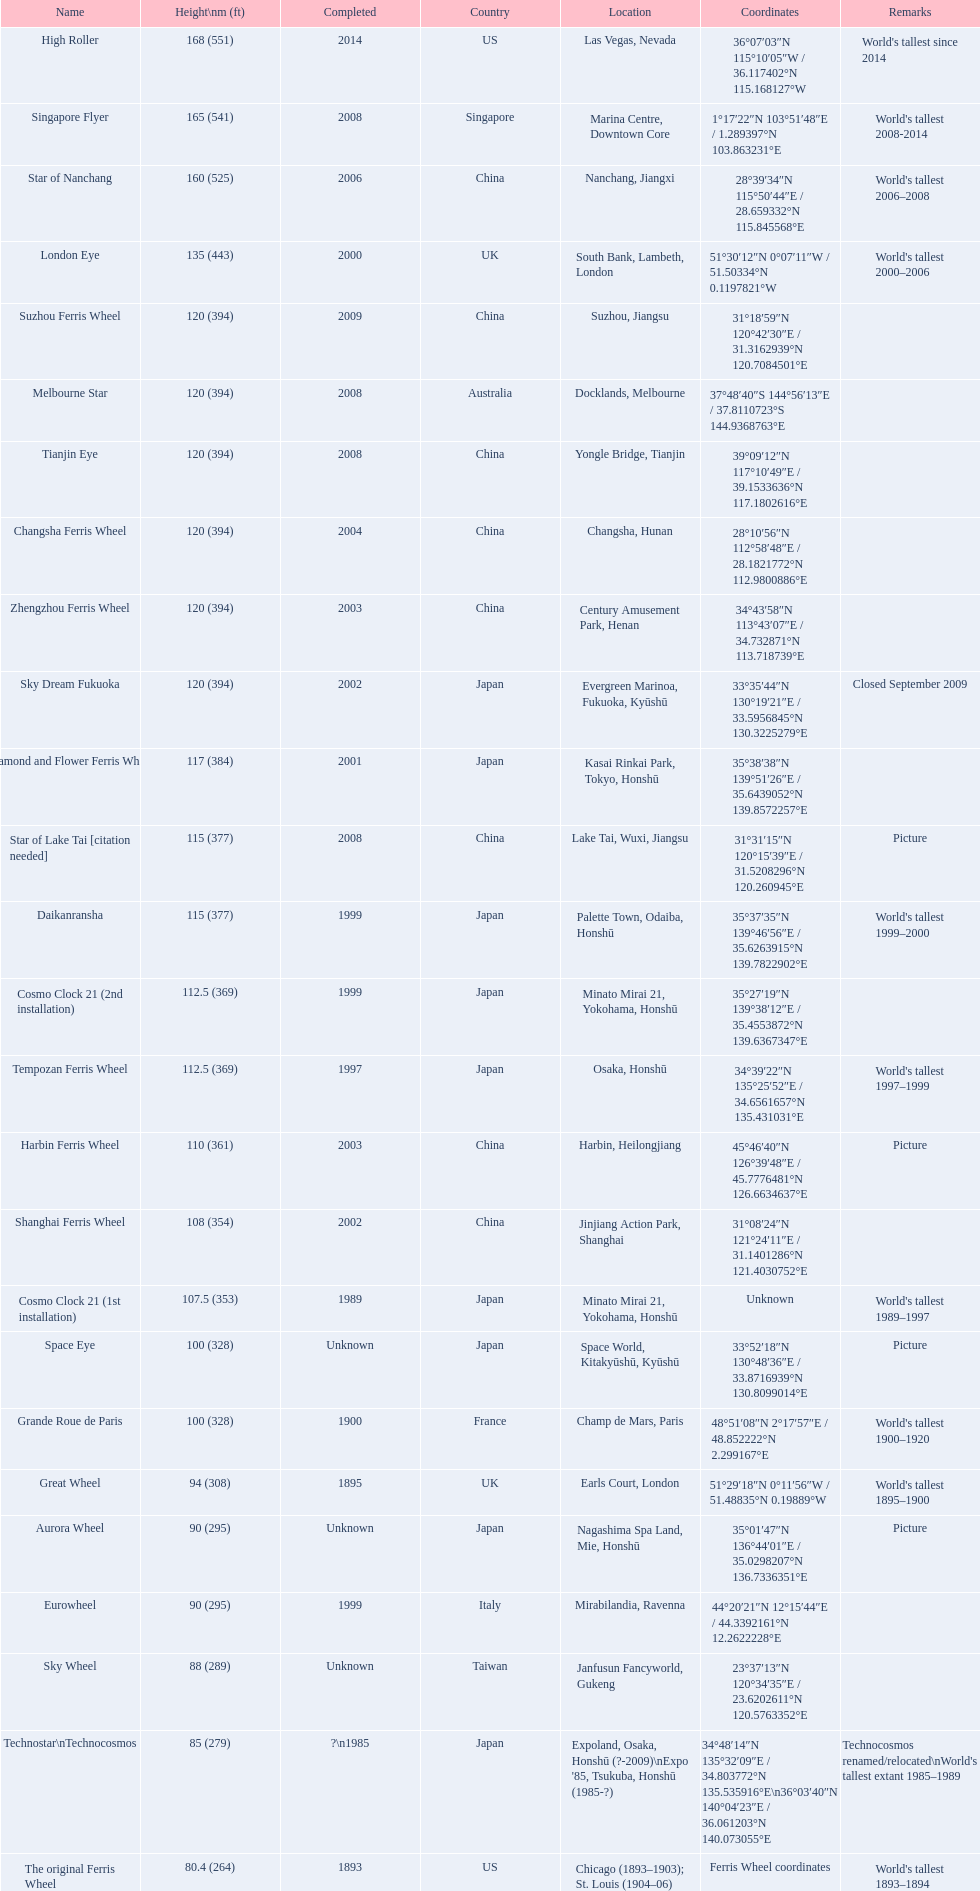What are the various names of the ferris wheels? High Roller, Singapore Flyer, Star of Nanchang, London Eye, Suzhou Ferris Wheel, Melbourne Star, Tianjin Eye, Changsha Ferris Wheel, Zhengzhou Ferris Wheel, Sky Dream Fukuoka, Diamond and Flower Ferris Wheel, Star of Lake Tai [citation needed], Daikanransha, Cosmo Clock 21 (2nd installation), Tempozan Ferris Wheel, Harbin Ferris Wheel, Shanghai Ferris Wheel, Cosmo Clock 21 (1st installation), Space Eye, Grande Roue de Paris, Great Wheel, Aurora Wheel, Eurowheel, Sky Wheel, Technostar\nTechnocosmos, The original Ferris Wheel. What was the elevation of each one? 168 (551), 165 (541), 160 (525), 135 (443), 120 (394), 120 (394), 120 (394), 120 (394), 120 (394), 120 (394), 117 (384), 115 (377), 115 (377), 112.5 (369), 112.5 (369), 110 (361), 108 (354), 107.5 (353), 100 (328), 100 (328), 94 (308), 90 (295), 90 (295), 88 (289), 85 (279), 80.4 (264). And when were they finished? 2014, 2008, 2006, 2000, 2009, 2008, 2008, 2004, 2003, 2002, 2001, 2008, 1999, 1999, 1997, 2003, 2002, 1989, Unknown, 1900, 1895, Unknown, 1999, Unknown, ?\n1985, 1893. Which ones were finalized in 2008? Singapore Flyer, Melbourne Star, Tianjin Eye, Star of Lake Tai [citation needed]. And among those ferris wheels, which had a height of 165 meters? Singapore Flyer. 